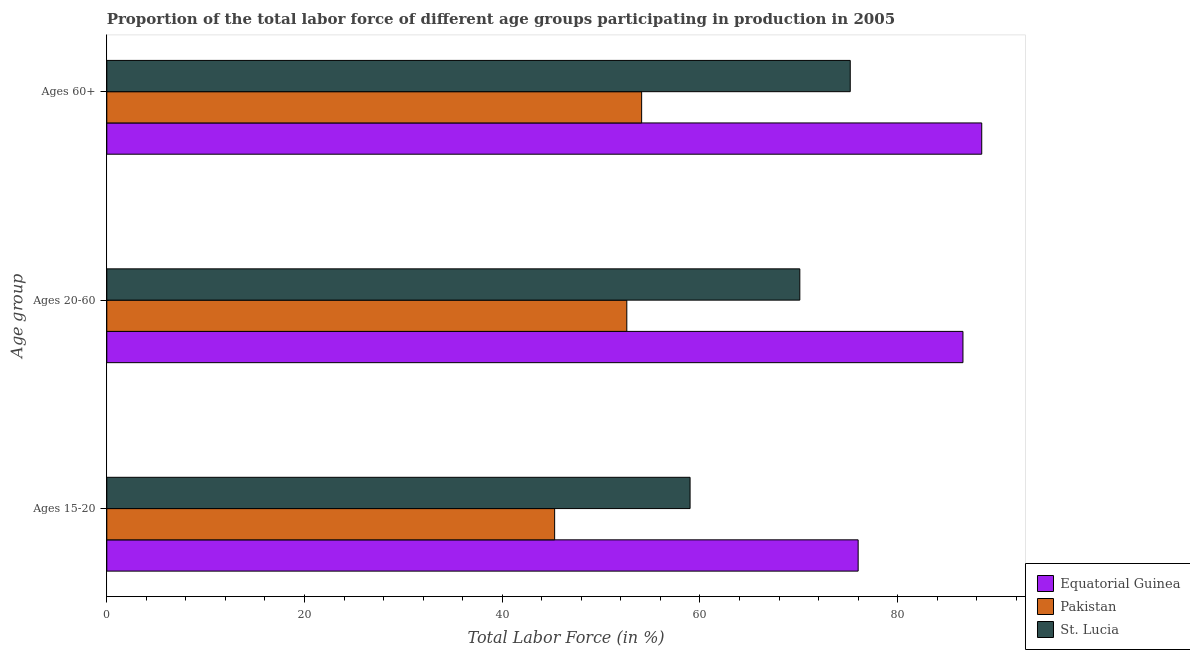How many groups of bars are there?
Make the answer very short. 3. Are the number of bars per tick equal to the number of legend labels?
Your response must be concise. Yes. How many bars are there on the 2nd tick from the top?
Your answer should be very brief. 3. What is the label of the 2nd group of bars from the top?
Provide a short and direct response. Ages 20-60. What is the percentage of labor force within the age group 20-60 in Equatorial Guinea?
Give a very brief answer. 86.6. Across all countries, what is the maximum percentage of labor force above age 60?
Your answer should be very brief. 88.5. Across all countries, what is the minimum percentage of labor force within the age group 15-20?
Your answer should be very brief. 45.3. In which country was the percentage of labor force above age 60 maximum?
Provide a short and direct response. Equatorial Guinea. In which country was the percentage of labor force within the age group 15-20 minimum?
Provide a short and direct response. Pakistan. What is the total percentage of labor force above age 60 in the graph?
Your answer should be compact. 217.8. What is the difference between the percentage of labor force within the age group 20-60 in St. Lucia and that in Pakistan?
Ensure brevity in your answer.  17.5. What is the difference between the percentage of labor force above age 60 in Pakistan and the percentage of labor force within the age group 15-20 in Equatorial Guinea?
Provide a short and direct response. -21.9. What is the average percentage of labor force above age 60 per country?
Your answer should be compact. 72.6. What is the difference between the percentage of labor force within the age group 15-20 and percentage of labor force within the age group 20-60 in Pakistan?
Provide a succinct answer. -7.3. What is the ratio of the percentage of labor force above age 60 in Pakistan to that in St. Lucia?
Ensure brevity in your answer.  0.72. What is the difference between the highest and the second highest percentage of labor force within the age group 15-20?
Make the answer very short. 17. What is the difference between the highest and the lowest percentage of labor force above age 60?
Provide a short and direct response. 34.4. In how many countries, is the percentage of labor force within the age group 20-60 greater than the average percentage of labor force within the age group 20-60 taken over all countries?
Keep it short and to the point. 2. Is the sum of the percentage of labor force above age 60 in Equatorial Guinea and Pakistan greater than the maximum percentage of labor force within the age group 15-20 across all countries?
Give a very brief answer. Yes. What does the 2nd bar from the top in Ages 15-20 represents?
Make the answer very short. Pakistan. What does the 1st bar from the bottom in Ages 60+ represents?
Your answer should be very brief. Equatorial Guinea. How many countries are there in the graph?
Give a very brief answer. 3. Does the graph contain any zero values?
Offer a very short reply. No. Where does the legend appear in the graph?
Give a very brief answer. Bottom right. How are the legend labels stacked?
Your response must be concise. Vertical. What is the title of the graph?
Ensure brevity in your answer.  Proportion of the total labor force of different age groups participating in production in 2005. Does "French Polynesia" appear as one of the legend labels in the graph?
Your answer should be compact. No. What is the label or title of the X-axis?
Give a very brief answer. Total Labor Force (in %). What is the label or title of the Y-axis?
Offer a very short reply. Age group. What is the Total Labor Force (in %) of Equatorial Guinea in Ages 15-20?
Ensure brevity in your answer.  76. What is the Total Labor Force (in %) in Pakistan in Ages 15-20?
Offer a terse response. 45.3. What is the Total Labor Force (in %) in St. Lucia in Ages 15-20?
Your response must be concise. 59. What is the Total Labor Force (in %) of Equatorial Guinea in Ages 20-60?
Your answer should be compact. 86.6. What is the Total Labor Force (in %) in Pakistan in Ages 20-60?
Provide a short and direct response. 52.6. What is the Total Labor Force (in %) in St. Lucia in Ages 20-60?
Make the answer very short. 70.1. What is the Total Labor Force (in %) of Equatorial Guinea in Ages 60+?
Offer a very short reply. 88.5. What is the Total Labor Force (in %) in Pakistan in Ages 60+?
Offer a terse response. 54.1. What is the Total Labor Force (in %) of St. Lucia in Ages 60+?
Keep it short and to the point. 75.2. Across all Age group, what is the maximum Total Labor Force (in %) of Equatorial Guinea?
Your answer should be very brief. 88.5. Across all Age group, what is the maximum Total Labor Force (in %) in Pakistan?
Keep it short and to the point. 54.1. Across all Age group, what is the maximum Total Labor Force (in %) in St. Lucia?
Ensure brevity in your answer.  75.2. Across all Age group, what is the minimum Total Labor Force (in %) in Pakistan?
Keep it short and to the point. 45.3. Across all Age group, what is the minimum Total Labor Force (in %) in St. Lucia?
Provide a short and direct response. 59. What is the total Total Labor Force (in %) in Equatorial Guinea in the graph?
Provide a short and direct response. 251.1. What is the total Total Labor Force (in %) in Pakistan in the graph?
Give a very brief answer. 152. What is the total Total Labor Force (in %) of St. Lucia in the graph?
Provide a succinct answer. 204.3. What is the difference between the Total Labor Force (in %) in Equatorial Guinea in Ages 15-20 and that in Ages 20-60?
Your answer should be very brief. -10.6. What is the difference between the Total Labor Force (in %) of Pakistan in Ages 15-20 and that in Ages 20-60?
Provide a short and direct response. -7.3. What is the difference between the Total Labor Force (in %) in St. Lucia in Ages 15-20 and that in Ages 20-60?
Offer a terse response. -11.1. What is the difference between the Total Labor Force (in %) of Equatorial Guinea in Ages 15-20 and that in Ages 60+?
Your response must be concise. -12.5. What is the difference between the Total Labor Force (in %) of Pakistan in Ages 15-20 and that in Ages 60+?
Your response must be concise. -8.8. What is the difference between the Total Labor Force (in %) of St. Lucia in Ages 15-20 and that in Ages 60+?
Your answer should be compact. -16.2. What is the difference between the Total Labor Force (in %) of Equatorial Guinea in Ages 20-60 and that in Ages 60+?
Your answer should be compact. -1.9. What is the difference between the Total Labor Force (in %) in Equatorial Guinea in Ages 15-20 and the Total Labor Force (in %) in Pakistan in Ages 20-60?
Keep it short and to the point. 23.4. What is the difference between the Total Labor Force (in %) of Pakistan in Ages 15-20 and the Total Labor Force (in %) of St. Lucia in Ages 20-60?
Give a very brief answer. -24.8. What is the difference between the Total Labor Force (in %) of Equatorial Guinea in Ages 15-20 and the Total Labor Force (in %) of Pakistan in Ages 60+?
Provide a short and direct response. 21.9. What is the difference between the Total Labor Force (in %) of Equatorial Guinea in Ages 15-20 and the Total Labor Force (in %) of St. Lucia in Ages 60+?
Offer a terse response. 0.8. What is the difference between the Total Labor Force (in %) of Pakistan in Ages 15-20 and the Total Labor Force (in %) of St. Lucia in Ages 60+?
Provide a succinct answer. -29.9. What is the difference between the Total Labor Force (in %) in Equatorial Guinea in Ages 20-60 and the Total Labor Force (in %) in Pakistan in Ages 60+?
Provide a short and direct response. 32.5. What is the difference between the Total Labor Force (in %) of Pakistan in Ages 20-60 and the Total Labor Force (in %) of St. Lucia in Ages 60+?
Your response must be concise. -22.6. What is the average Total Labor Force (in %) of Equatorial Guinea per Age group?
Your answer should be compact. 83.7. What is the average Total Labor Force (in %) of Pakistan per Age group?
Offer a very short reply. 50.67. What is the average Total Labor Force (in %) of St. Lucia per Age group?
Provide a short and direct response. 68.1. What is the difference between the Total Labor Force (in %) in Equatorial Guinea and Total Labor Force (in %) in Pakistan in Ages 15-20?
Your answer should be very brief. 30.7. What is the difference between the Total Labor Force (in %) in Pakistan and Total Labor Force (in %) in St. Lucia in Ages 15-20?
Provide a succinct answer. -13.7. What is the difference between the Total Labor Force (in %) of Pakistan and Total Labor Force (in %) of St. Lucia in Ages 20-60?
Your answer should be very brief. -17.5. What is the difference between the Total Labor Force (in %) in Equatorial Guinea and Total Labor Force (in %) in Pakistan in Ages 60+?
Your answer should be very brief. 34.4. What is the difference between the Total Labor Force (in %) of Pakistan and Total Labor Force (in %) of St. Lucia in Ages 60+?
Your response must be concise. -21.1. What is the ratio of the Total Labor Force (in %) in Equatorial Guinea in Ages 15-20 to that in Ages 20-60?
Provide a succinct answer. 0.88. What is the ratio of the Total Labor Force (in %) in Pakistan in Ages 15-20 to that in Ages 20-60?
Your answer should be very brief. 0.86. What is the ratio of the Total Labor Force (in %) in St. Lucia in Ages 15-20 to that in Ages 20-60?
Provide a short and direct response. 0.84. What is the ratio of the Total Labor Force (in %) of Equatorial Guinea in Ages 15-20 to that in Ages 60+?
Make the answer very short. 0.86. What is the ratio of the Total Labor Force (in %) of Pakistan in Ages 15-20 to that in Ages 60+?
Make the answer very short. 0.84. What is the ratio of the Total Labor Force (in %) of St. Lucia in Ages 15-20 to that in Ages 60+?
Offer a terse response. 0.78. What is the ratio of the Total Labor Force (in %) of Equatorial Guinea in Ages 20-60 to that in Ages 60+?
Provide a short and direct response. 0.98. What is the ratio of the Total Labor Force (in %) in Pakistan in Ages 20-60 to that in Ages 60+?
Give a very brief answer. 0.97. What is the ratio of the Total Labor Force (in %) of St. Lucia in Ages 20-60 to that in Ages 60+?
Ensure brevity in your answer.  0.93. What is the difference between the highest and the second highest Total Labor Force (in %) in Pakistan?
Offer a terse response. 1.5. What is the difference between the highest and the lowest Total Labor Force (in %) of Equatorial Guinea?
Offer a terse response. 12.5. 